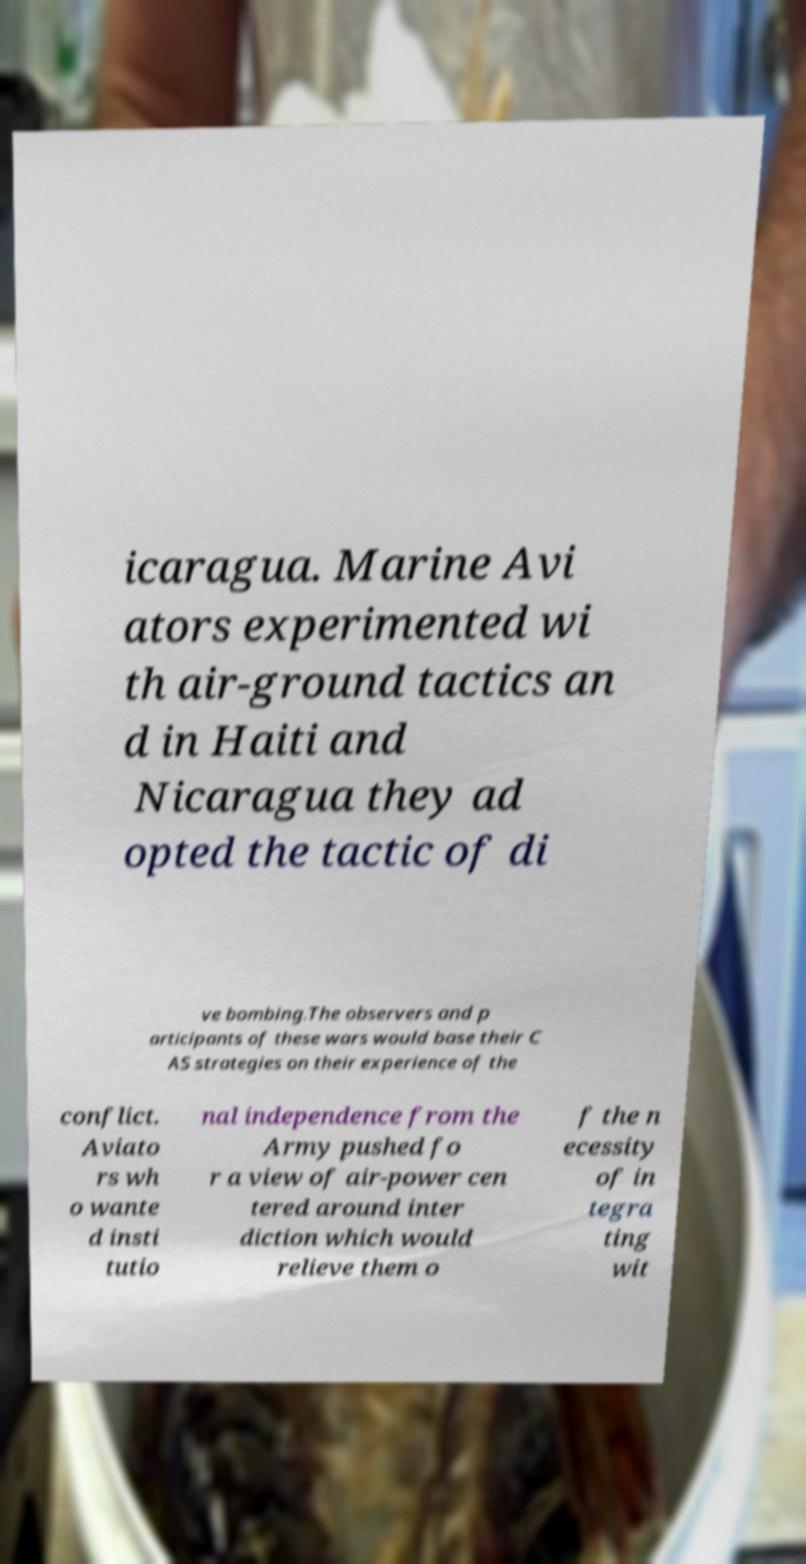For documentation purposes, I need the text within this image transcribed. Could you provide that? icaragua. Marine Avi ators experimented wi th air-ground tactics an d in Haiti and Nicaragua they ad opted the tactic of di ve bombing.The observers and p articipants of these wars would base their C AS strategies on their experience of the conflict. Aviato rs wh o wante d insti tutio nal independence from the Army pushed fo r a view of air-power cen tered around inter diction which would relieve them o f the n ecessity of in tegra ting wit 